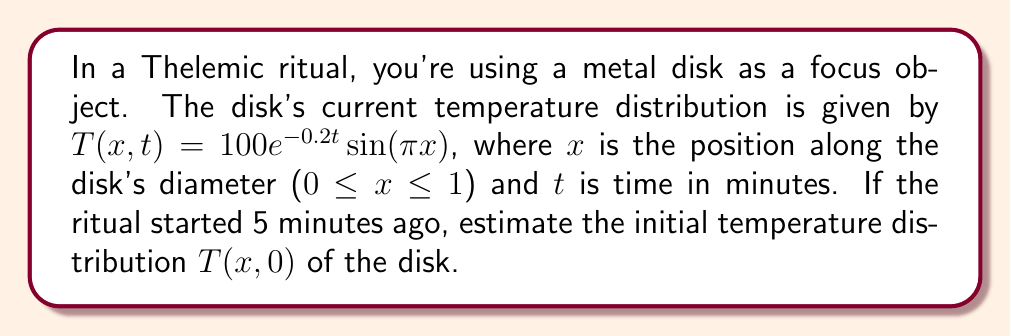Help me with this question. Let's approach this step-by-step:

1) The given temperature distribution is:
   $$T(x,t) = 100e^{-0.2t}\sin(\pi x)$$

2) To find the initial temperature distribution, we need to set $t = 0$:
   $$T(x,0) = 100e^{-0.2(0)}\sin(\pi x)$$

3) Simplify:
   $$T(x,0) = 100e^0\sin(\pi x)$$

4) Since $e^0 = 1$, we get:
   $$T(x,0) = 100\sin(\pi x)$$

5) This is the initial temperature distribution function.

6) To verify, we can check if this matches the current temperature after 5 minutes:
   $$T(x,5) = 100e^{-0.2(5)}\sin(\pi x) = 100e^{-1}\sin(\pi x) \approx 36.79\sin(\pi x)$$

7) Indeed, this matches the given current temperature distribution, confirming our solution.
Answer: $T(x,0) = 100\sin(\pi x)$ 